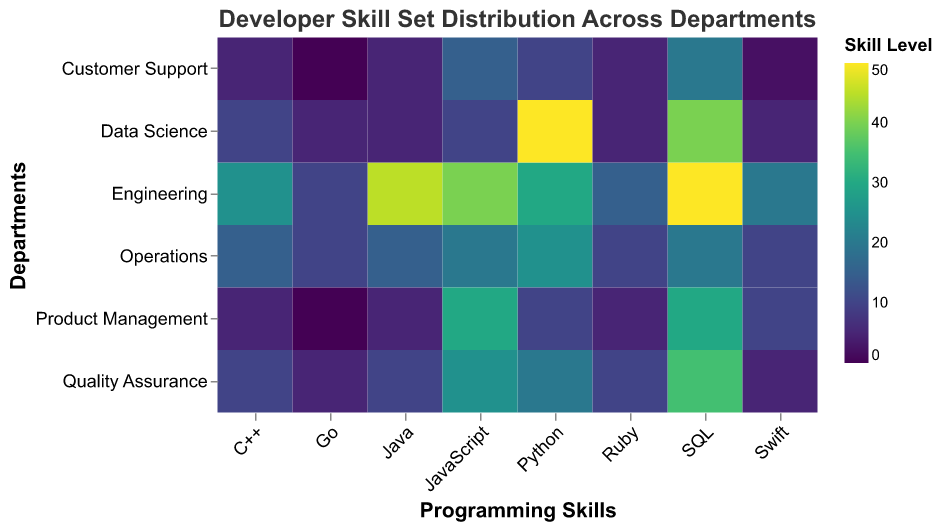What is the skill level of Java in the Engineering department? The heatmap's cell at the intersection of the "Engineering" row and "Java" column indicates the value, which is 45.
Answer: 45 Which department has the highest skill level for Python? By inspecting the column for Python across all departments, it is evident that "Data Science" has the highest skill level for Python at 50.
Answer: Data Science What is the total skill level for SQL across all departments? Sum the skill levels for SQL across all departments: 50 (Engineering) + 40 (Data Science) + 35 (Quality Assurance) + 20 (Operations) + 30 (Product Management) + 20 (Customer Support) = 195.
Answer: 195 Which department has a higher skill level in JavaScript: Quality Assurance or Product Management? Compare the JavaScript skill levels in "Quality Assurance" (25) and "Product Management" (30).
Answer: Product Management What is the average skill level of Swift across all departments? Sum the values of Swift across all departments and divide by the number of departments: (20 + 5 + 5 + 10 + 10 + 2) / 6 = 8.67.
Answer: 8.67 Which skill has the lowest range of values across the departments? Calculate the range (difference between max and min values) for each skill, and find the one with the smallest range: Java (45-5=40), Python (50-10=40), JavaScript (40-10=30), C++ (25-5=20), SQL (50-20=30), Go (10-0=10), Ruby (15-5=10), Swift (20-2=18). The smallest range is for Go and Ruby, both 10.
Answer: Go and Ruby What is the difference in Python skill levels between Engineering and Data Science? Subtract the Python skill level in Engineering (30) from that in Data Science (50): 50 - 30 = 20.
Answer: 20 How many departments have more than 10 skill level in Swift? Count the departments with Swift skill level greater than 10: Engineering (20), Operations (10), Product Management (10). There are two.
Answer: 2 What Programming Skill is least prevalent in the Product Management department? Identify the skill with the lowest value in the Product Management row: Go at 0.
Answer: Go Which department has the most balanced skill set (least variation in skill values)? Assess the skill variations for each department and find the one with the least variation. Engineering: (50-10=40), Data Science: (50-5=45), Quality Assurance: (35-5=30), Operations: (25-10=15), Product Management: (30-0=30), Customer Support: (20-0=20). Operations has the smallest range.
Answer: Operations 